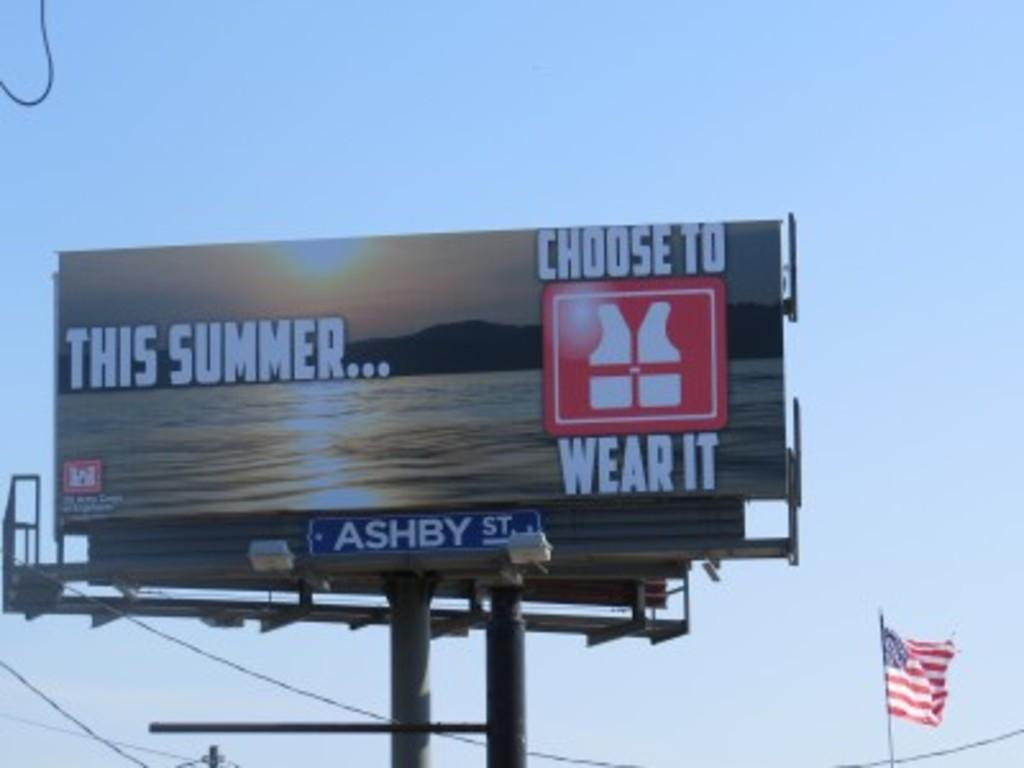Provide a one-sentence caption for the provided image. A billboard is advertising wearing a life jacket this summer. 